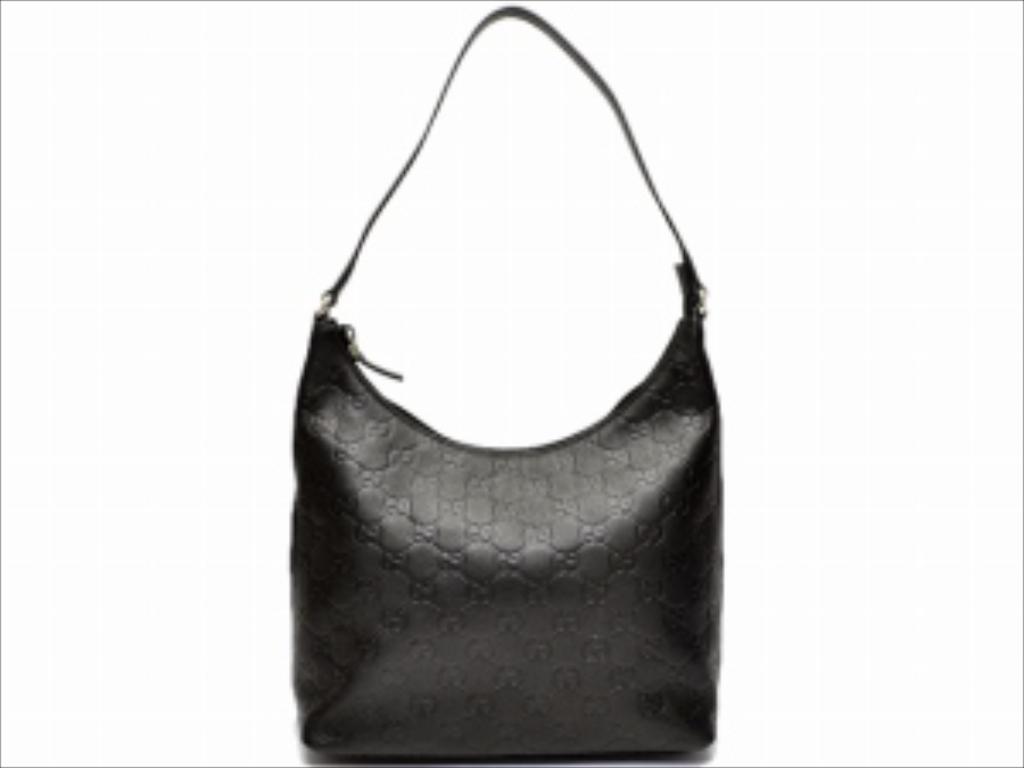Can you describe this image briefly? In this image i can see a handbag, 